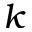<formula> <loc_0><loc_0><loc_500><loc_500>k</formula> 